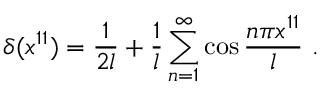<formula> <loc_0><loc_0><loc_500><loc_500>\delta ( x ^ { 1 1 } ) = { \frac { 1 } { 2 l } } + { \frac { 1 } { l } } \sum _ { n = 1 } ^ { \infty } \cos { \frac { n \pi x ^ { 1 1 } } { l } } \ .</formula> 